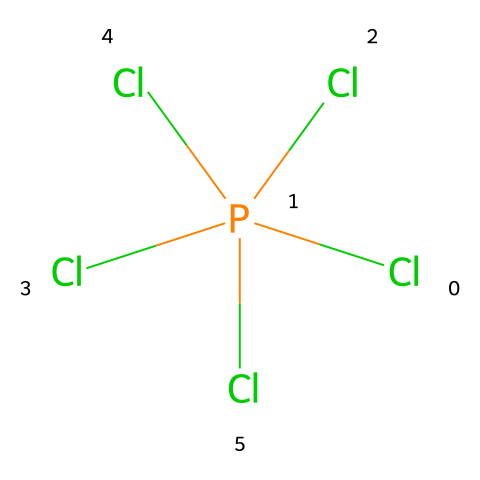What is the central atom in this compound? The SMILES representation indicates that phosphorus (P) is the central atom as it is surrounded by the chlorine atoms.
Answer: phosphorus How many chlorine atoms are present in phosphorus pentachloride? The SMILES notation shows five chlorine (Cl) atoms attached to the phosphorus (P) atom.
Answer: five Is this compound a Lewis acid or a Lewis base? Because phosphorus pentachloride can accept a pair of electrons due to its empty d-orbitals, it acts as a Lewis acid.
Answer: Lewis acid What type of molecular geometry does phosphorus pentachloride exhibit? Due to the arrangement of five chloride atoms around a central phosphorus atom, it exhibits a trigonal bipyramidal geometry, characterized by one atom above and one below the plane of three other atoms.
Answer: trigonal bipyramidal What does the presence of a hypervalent phosphorus atom indicate about its bonding capacity? The presence of phosphorus in a hypervalent state, surrounded by five chlorines, indicates that phosphorus can expand its octet, allowing for more than four bonding partners.
Answer: expanded octet How many non-bonding electron pairs are on the phosphorus atom in this compound? The phosphorus atom in phosphorus pentachloride has no non-bonding electron pairs, as all available valence electrons are involved in bonding with the chlorine atoms.
Answer: zero 